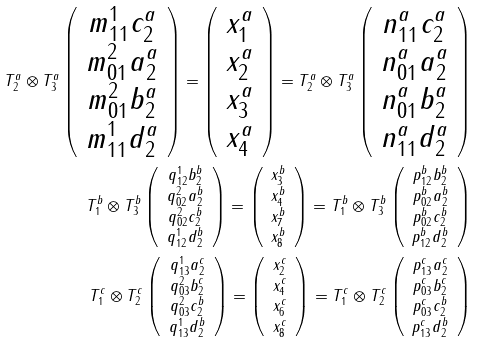<formula> <loc_0><loc_0><loc_500><loc_500>T _ { 2 } ^ { a } \otimes T _ { 3 } ^ { a } \left ( \begin{array} { c } m _ { 1 1 } ^ { 1 } c _ { 2 } ^ { a } \\ m _ { 0 1 } ^ { 2 } a _ { 2 } ^ { a } \\ m _ { 0 1 } ^ { 2 } b _ { 2 } ^ { a } \\ m _ { 1 1 } ^ { 1 } d _ { 2 } ^ { a } \end{array} \right ) = \left ( \begin{array} { c } x _ { 1 } ^ { a } \\ x _ { 2 } ^ { a } \\ x _ { 3 } ^ { a } \\ x _ { 4 } ^ { a } \end{array} \right ) = T _ { 2 } ^ { a } \otimes T _ { 3 } ^ { a } \left ( \begin{array} { c } n _ { 1 1 } ^ { a } c _ { 2 } ^ { a } \\ n _ { 0 1 } ^ { a } a _ { 2 } ^ { a } \\ n _ { 0 1 } ^ { a } b _ { 2 } ^ { a } \\ n _ { 1 1 } ^ { a } d _ { 2 } ^ { a } \end{array} \right ) \\ T _ { 1 } ^ { b } \otimes T _ { 3 } ^ { b } \left ( \begin{array} { c } q _ { 1 2 } ^ { 1 } b _ { 2 } ^ { b } \\ q _ { 0 2 } ^ { 2 } a _ { 2 } ^ { b } \\ q _ { 0 2 } ^ { 2 } c _ { 2 } ^ { b } \\ q _ { 1 2 } ^ { 1 } d _ { 2 } ^ { b } \end{array} \right ) = \left ( \begin{array} { c } x _ { 3 } ^ { b } \\ x _ { 4 } ^ { b } \\ x _ { 7 } ^ { b } \\ x _ { 8 } ^ { b } \end{array} \right ) = T _ { 1 } ^ { b } \otimes T _ { 3 } ^ { b } \left ( \begin{array} { c } p _ { 1 2 } ^ { b } b _ { 2 } ^ { b } \\ p _ { 0 2 } ^ { b } a _ { 2 } ^ { b } \\ p _ { 0 2 } ^ { b } c _ { 2 } ^ { b } \\ p _ { 1 2 } ^ { b } d _ { 2 } ^ { b } \end{array} \right ) \\ T _ { 1 } ^ { c } \otimes T _ { 2 } ^ { c } \left ( \begin{array} { c } q _ { 1 3 } ^ { 1 } a _ { 2 } ^ { c } \\ q _ { 0 3 } ^ { 2 } b _ { 2 } ^ { c } \\ q _ { 0 3 } ^ { 2 } c _ { 2 } ^ { b } \\ q _ { 1 3 } ^ { 1 } d _ { 2 } ^ { b } \end{array} \right ) = \left ( \begin{array} { c } x _ { 2 } ^ { c } \\ x _ { 4 } ^ { c } \\ x _ { 6 } ^ { c } \\ x _ { 8 } ^ { c } \end{array} \right ) = T _ { 1 } ^ { c } \otimes T _ { 2 } ^ { c } \left ( \begin{array} { c } p _ { 1 3 } ^ { c } a _ { 2 } ^ { c } \\ p _ { 0 3 } ^ { c } b _ { 2 } ^ { c } \\ p _ { 0 3 } ^ { c } c _ { 2 } ^ { b } \\ p _ { 1 3 } ^ { c } d _ { 2 } ^ { b } \end{array} \right )</formula> 